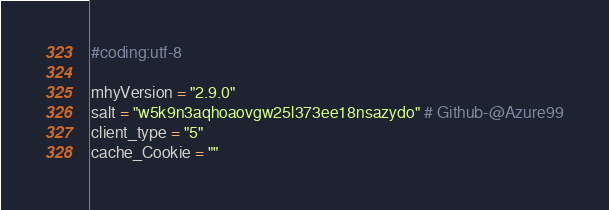Convert code to text. <code><loc_0><loc_0><loc_500><loc_500><_Python_>#coding:utf-8

mhyVersion = "2.9.0"
salt = "w5k9n3aqhoaovgw25l373ee18nsazydo" # Github-@Azure99
client_type = "5"
cache_Cookie = ""
</code> 